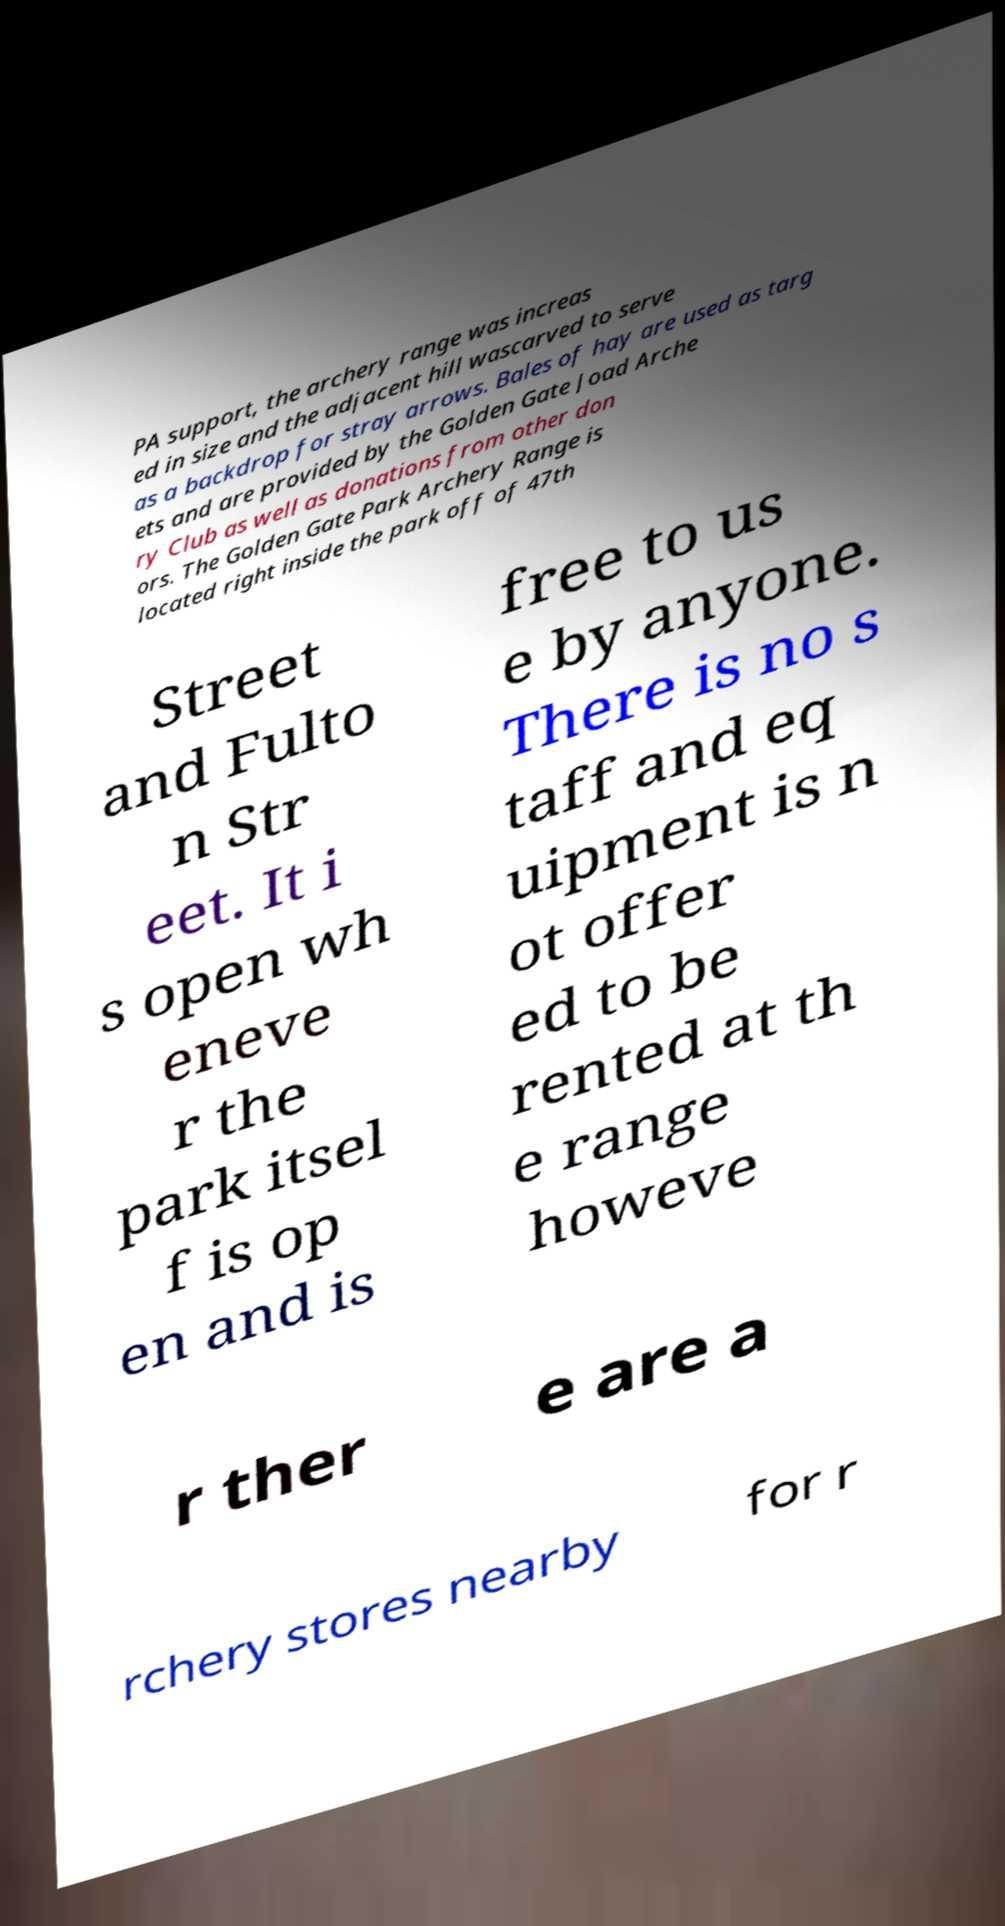Please read and relay the text visible in this image. What does it say? PA support, the archery range was increas ed in size and the adjacent hill wascarved to serve as a backdrop for stray arrows. Bales of hay are used as targ ets and are provided by the Golden Gate Joad Arche ry Club as well as donations from other don ors. The Golden Gate Park Archery Range is located right inside the park off of 47th Street and Fulto n Str eet. It i s open wh eneve r the park itsel f is op en and is free to us e by anyone. There is no s taff and eq uipment is n ot offer ed to be rented at th e range howeve r ther e are a rchery stores nearby for r 